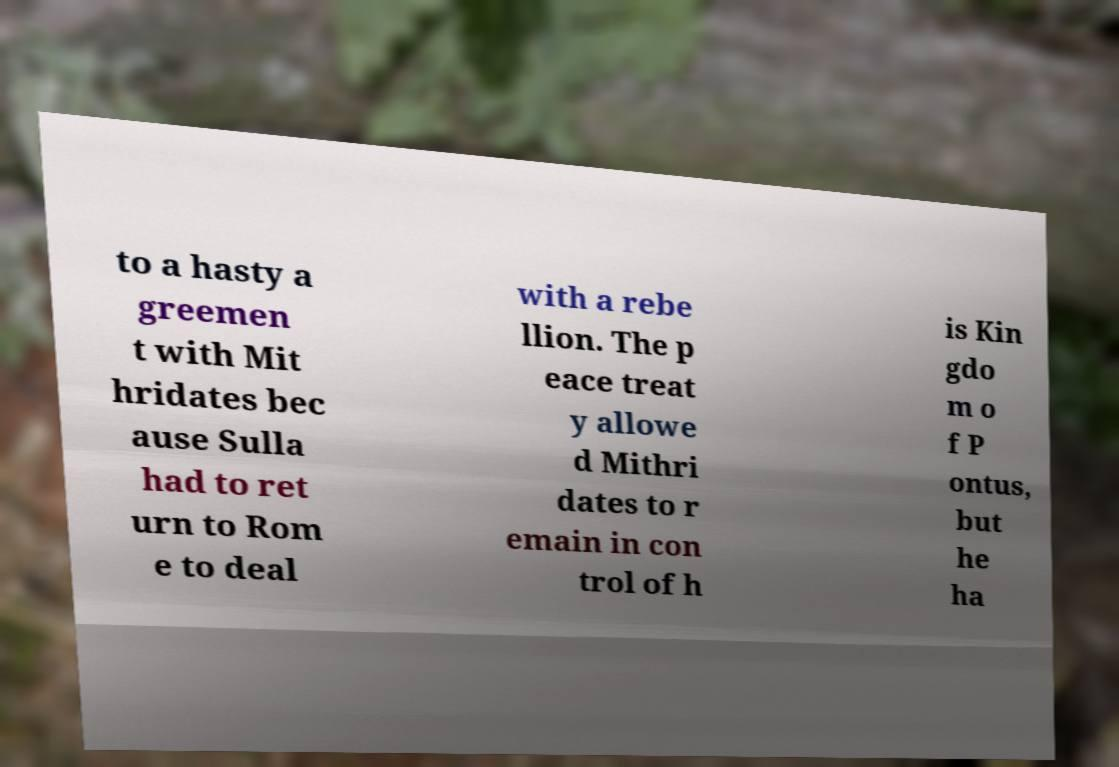Can you read and provide the text displayed in the image?This photo seems to have some interesting text. Can you extract and type it out for me? to a hasty a greemen t with Mit hridates bec ause Sulla had to ret urn to Rom e to deal with a rebe llion. The p eace treat y allowe d Mithri dates to r emain in con trol of h is Kin gdo m o f P ontus, but he ha 